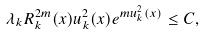Convert formula to latex. <formula><loc_0><loc_0><loc_500><loc_500>\lambda _ { k } R _ { k } ^ { 2 m } ( x ) u _ { k } ^ { 2 } ( x ) e ^ { m u _ { k } ^ { 2 } ( x ) } \leq C ,</formula> 